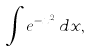Convert formula to latex. <formula><loc_0><loc_0><loc_500><loc_500>\int e ^ { - x ^ { 2 } } \, d x ,</formula> 